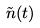Convert formula to latex. <formula><loc_0><loc_0><loc_500><loc_500>\tilde { n } ( t )</formula> 